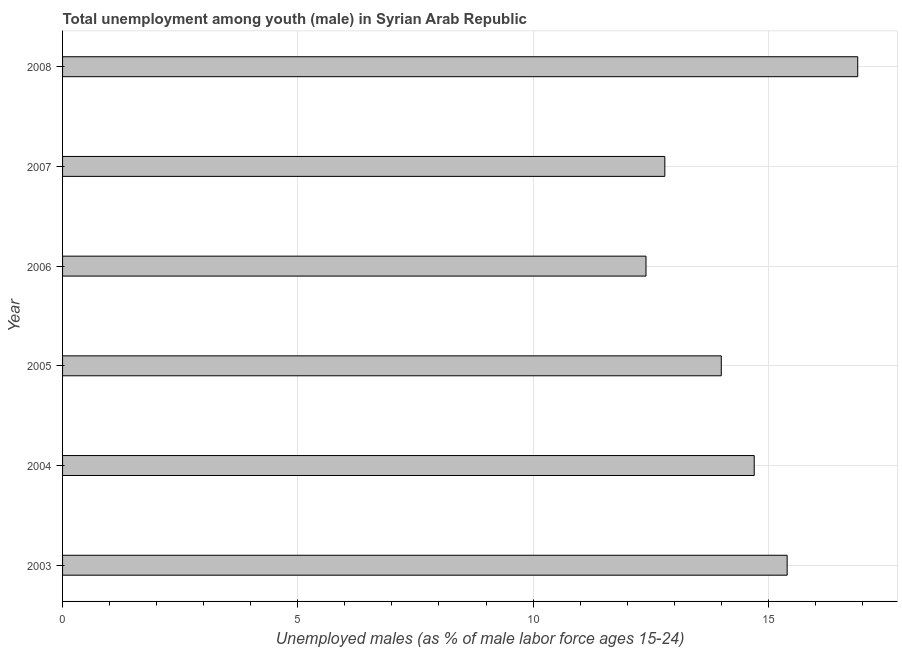Does the graph contain any zero values?
Your response must be concise. No. What is the title of the graph?
Your response must be concise. Total unemployment among youth (male) in Syrian Arab Republic. What is the label or title of the X-axis?
Keep it short and to the point. Unemployed males (as % of male labor force ages 15-24). What is the label or title of the Y-axis?
Make the answer very short. Year. What is the unemployed male youth population in 2006?
Your answer should be very brief. 12.4. Across all years, what is the maximum unemployed male youth population?
Ensure brevity in your answer.  16.9. Across all years, what is the minimum unemployed male youth population?
Offer a terse response. 12.4. What is the sum of the unemployed male youth population?
Ensure brevity in your answer.  86.2. What is the difference between the unemployed male youth population in 2003 and 2005?
Your answer should be compact. 1.4. What is the average unemployed male youth population per year?
Give a very brief answer. 14.37. What is the median unemployed male youth population?
Make the answer very short. 14.35. In how many years, is the unemployed male youth population greater than 11 %?
Provide a succinct answer. 6. What is the ratio of the unemployed male youth population in 2003 to that in 2004?
Your response must be concise. 1.05. What is the difference between the highest and the second highest unemployed male youth population?
Your answer should be compact. 1.5. Is the sum of the unemployed male youth population in 2005 and 2008 greater than the maximum unemployed male youth population across all years?
Ensure brevity in your answer.  Yes. In how many years, is the unemployed male youth population greater than the average unemployed male youth population taken over all years?
Offer a terse response. 3. How many bars are there?
Ensure brevity in your answer.  6. Are all the bars in the graph horizontal?
Your answer should be very brief. Yes. What is the difference between two consecutive major ticks on the X-axis?
Keep it short and to the point. 5. What is the Unemployed males (as % of male labor force ages 15-24) in 2003?
Provide a short and direct response. 15.4. What is the Unemployed males (as % of male labor force ages 15-24) in 2004?
Make the answer very short. 14.7. What is the Unemployed males (as % of male labor force ages 15-24) of 2006?
Your response must be concise. 12.4. What is the Unemployed males (as % of male labor force ages 15-24) of 2007?
Ensure brevity in your answer.  12.8. What is the Unemployed males (as % of male labor force ages 15-24) of 2008?
Keep it short and to the point. 16.9. What is the difference between the Unemployed males (as % of male labor force ages 15-24) in 2003 and 2004?
Offer a terse response. 0.7. What is the difference between the Unemployed males (as % of male labor force ages 15-24) in 2003 and 2005?
Ensure brevity in your answer.  1.4. What is the difference between the Unemployed males (as % of male labor force ages 15-24) in 2004 and 2006?
Your response must be concise. 2.3. What is the difference between the Unemployed males (as % of male labor force ages 15-24) in 2005 and 2007?
Make the answer very short. 1.2. What is the difference between the Unemployed males (as % of male labor force ages 15-24) in 2006 and 2007?
Provide a short and direct response. -0.4. What is the difference between the Unemployed males (as % of male labor force ages 15-24) in 2006 and 2008?
Ensure brevity in your answer.  -4.5. What is the ratio of the Unemployed males (as % of male labor force ages 15-24) in 2003 to that in 2004?
Offer a terse response. 1.05. What is the ratio of the Unemployed males (as % of male labor force ages 15-24) in 2003 to that in 2005?
Keep it short and to the point. 1.1. What is the ratio of the Unemployed males (as % of male labor force ages 15-24) in 2003 to that in 2006?
Offer a terse response. 1.24. What is the ratio of the Unemployed males (as % of male labor force ages 15-24) in 2003 to that in 2007?
Provide a short and direct response. 1.2. What is the ratio of the Unemployed males (as % of male labor force ages 15-24) in 2003 to that in 2008?
Give a very brief answer. 0.91. What is the ratio of the Unemployed males (as % of male labor force ages 15-24) in 2004 to that in 2005?
Provide a succinct answer. 1.05. What is the ratio of the Unemployed males (as % of male labor force ages 15-24) in 2004 to that in 2006?
Make the answer very short. 1.19. What is the ratio of the Unemployed males (as % of male labor force ages 15-24) in 2004 to that in 2007?
Provide a succinct answer. 1.15. What is the ratio of the Unemployed males (as % of male labor force ages 15-24) in 2004 to that in 2008?
Give a very brief answer. 0.87. What is the ratio of the Unemployed males (as % of male labor force ages 15-24) in 2005 to that in 2006?
Make the answer very short. 1.13. What is the ratio of the Unemployed males (as % of male labor force ages 15-24) in 2005 to that in 2007?
Give a very brief answer. 1.09. What is the ratio of the Unemployed males (as % of male labor force ages 15-24) in 2005 to that in 2008?
Your answer should be compact. 0.83. What is the ratio of the Unemployed males (as % of male labor force ages 15-24) in 2006 to that in 2007?
Offer a terse response. 0.97. What is the ratio of the Unemployed males (as % of male labor force ages 15-24) in 2006 to that in 2008?
Keep it short and to the point. 0.73. What is the ratio of the Unemployed males (as % of male labor force ages 15-24) in 2007 to that in 2008?
Provide a succinct answer. 0.76. 